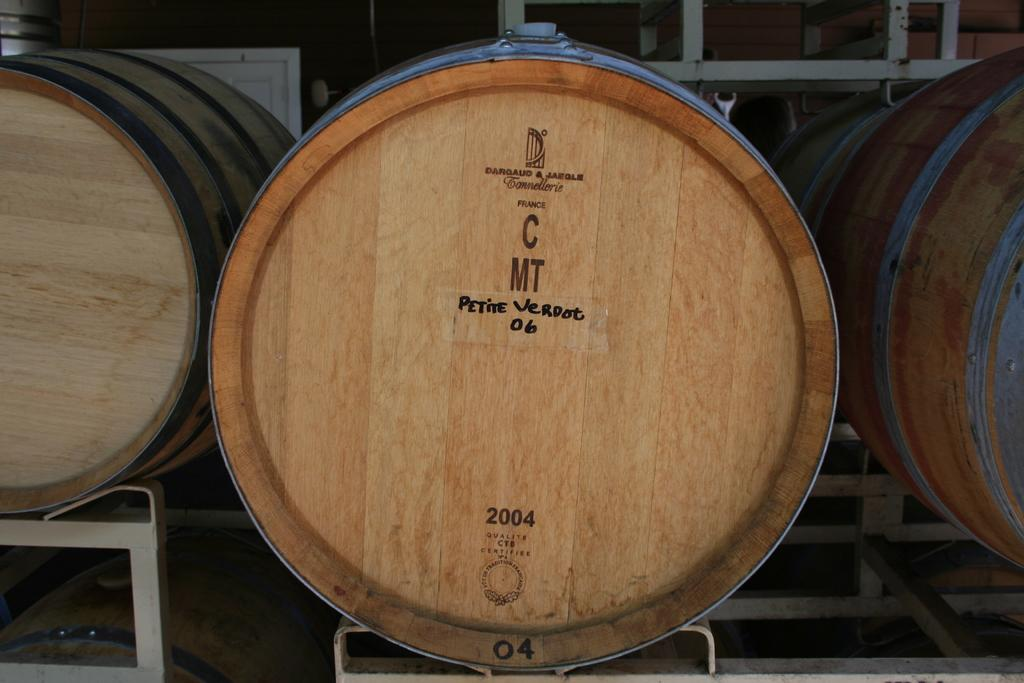What material is present in the image? There is wood in the image. Where is the faucet located in the image? There is no faucet present in the image. How many apples are on the wood in the image? There is no mention of apples in the image, so we cannot determine their presence or quantity. 